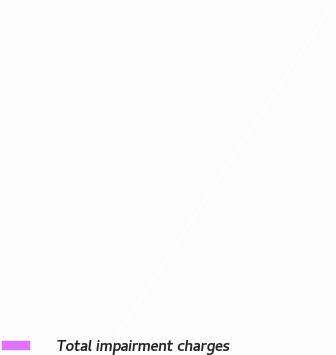Convert chart. <chart><loc_0><loc_0><loc_500><loc_500><pie_chart><fcel>Total impairment charges<nl><fcel>100.0%<nl></chart> 